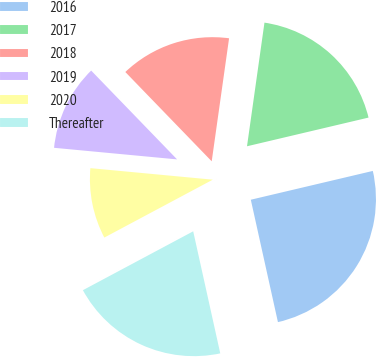<chart> <loc_0><loc_0><loc_500><loc_500><pie_chart><fcel>2016<fcel>2017<fcel>2018<fcel>2019<fcel>2020<fcel>Thereafter<nl><fcel>25.22%<fcel>19.08%<fcel>14.47%<fcel>11.27%<fcel>9.3%<fcel>20.67%<nl></chart> 